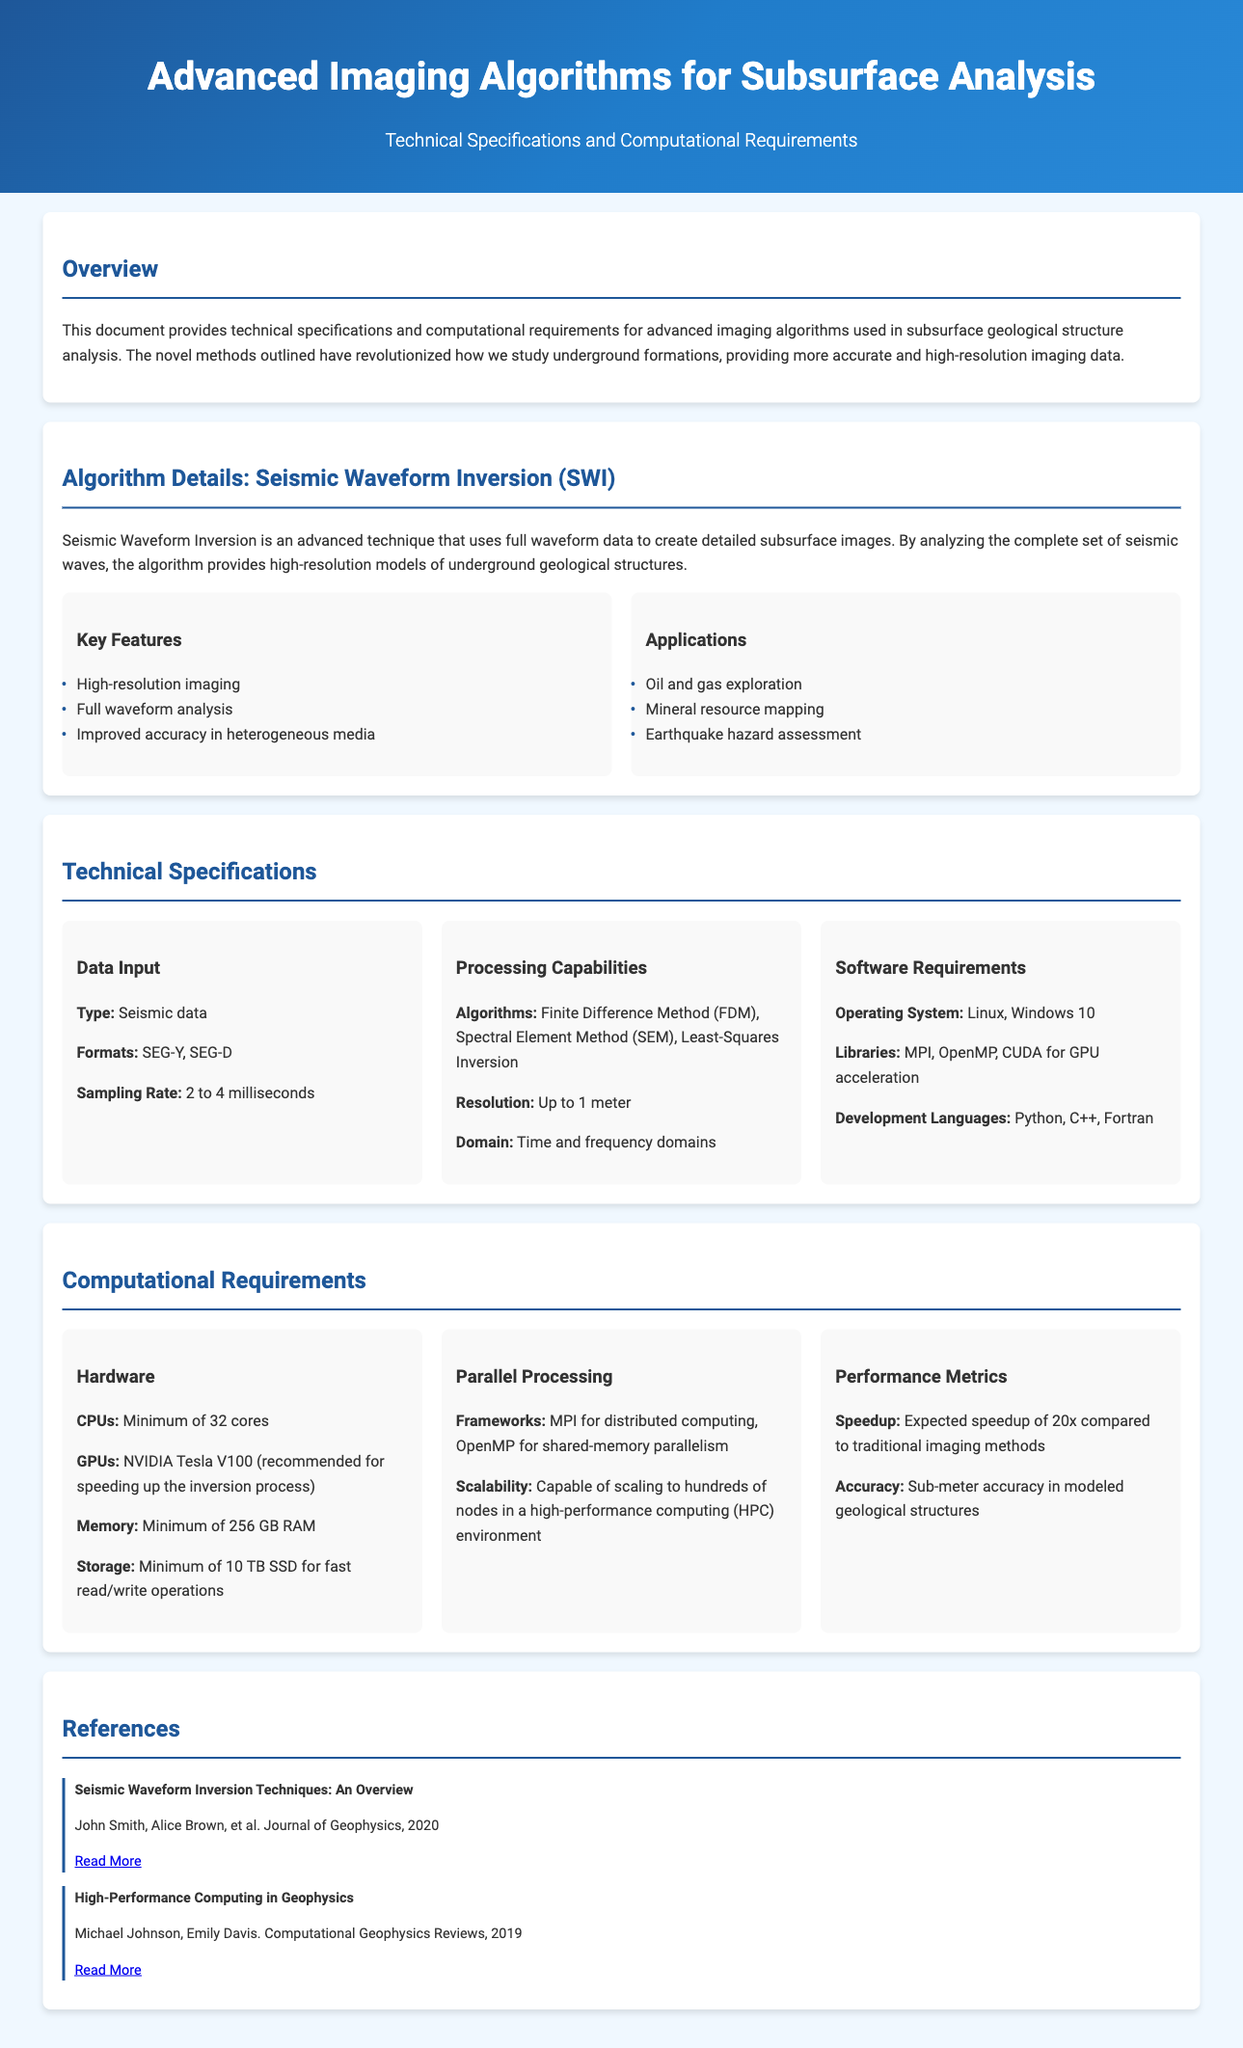What is the main technique described in the document? The document centers around Seismic Waveform Inversion as an advanced imaging technique for subsurface analysis.
Answer: Seismic Waveform Inversion What operating systems are supported? The software requirements list Linux and Windows 10 as the supported operating systems.
Answer: Linux, Windows 10 What is the minimum RAM required? The computational requirements specify a minimum of 256 GB RAM for effective processing.
Answer: 256 GB RAM What is the expected speedup compared to traditional methods? According to the performance metrics, the expected speedup is 20 times faster than traditional imaging methods.
Answer: 20x What types of data formats are accepted? The technical specifications indicate that SEG-Y and SEG-D are the formats for seismic data input.
Answer: SEG-Y, SEG-D What is the resolution capability of the algorithms? The processing capabilities section states that the resolution can reach up to 1 meter.
Answer: Up to 1 meter Which GPU is recommended for this method? The computational requirements suggest the NVIDIA Tesla V100 as the recommended GPU for enhancing the inversion process.
Answer: NVIDIA Tesla V100 What are the hardware requirements for CPUs? It specifies that a minimum of 32 cores is required for the CPU hardware.
Answer: Minimum of 32 cores What applications are mentioned for the technique? The applications listed include oil and gas exploration, mineral resource mapping, and earthquake hazard assessment.
Answer: Oil and gas exploration, mineral resource mapping, earthquake hazard assessment 